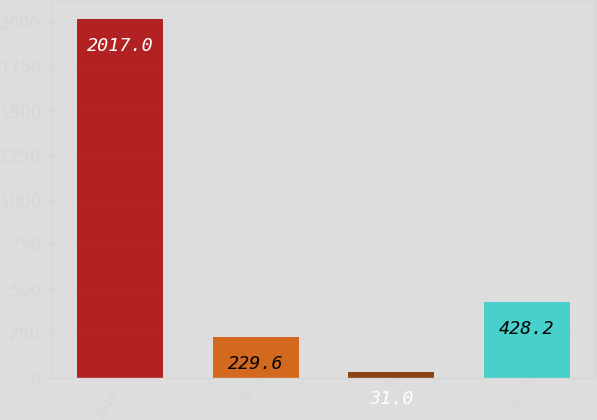<chart> <loc_0><loc_0><loc_500><loc_500><bar_chart><fcel>2018<fcel>70<fcel>30<fcel>100<nl><fcel>2017<fcel>229.6<fcel>31<fcel>428.2<nl></chart> 